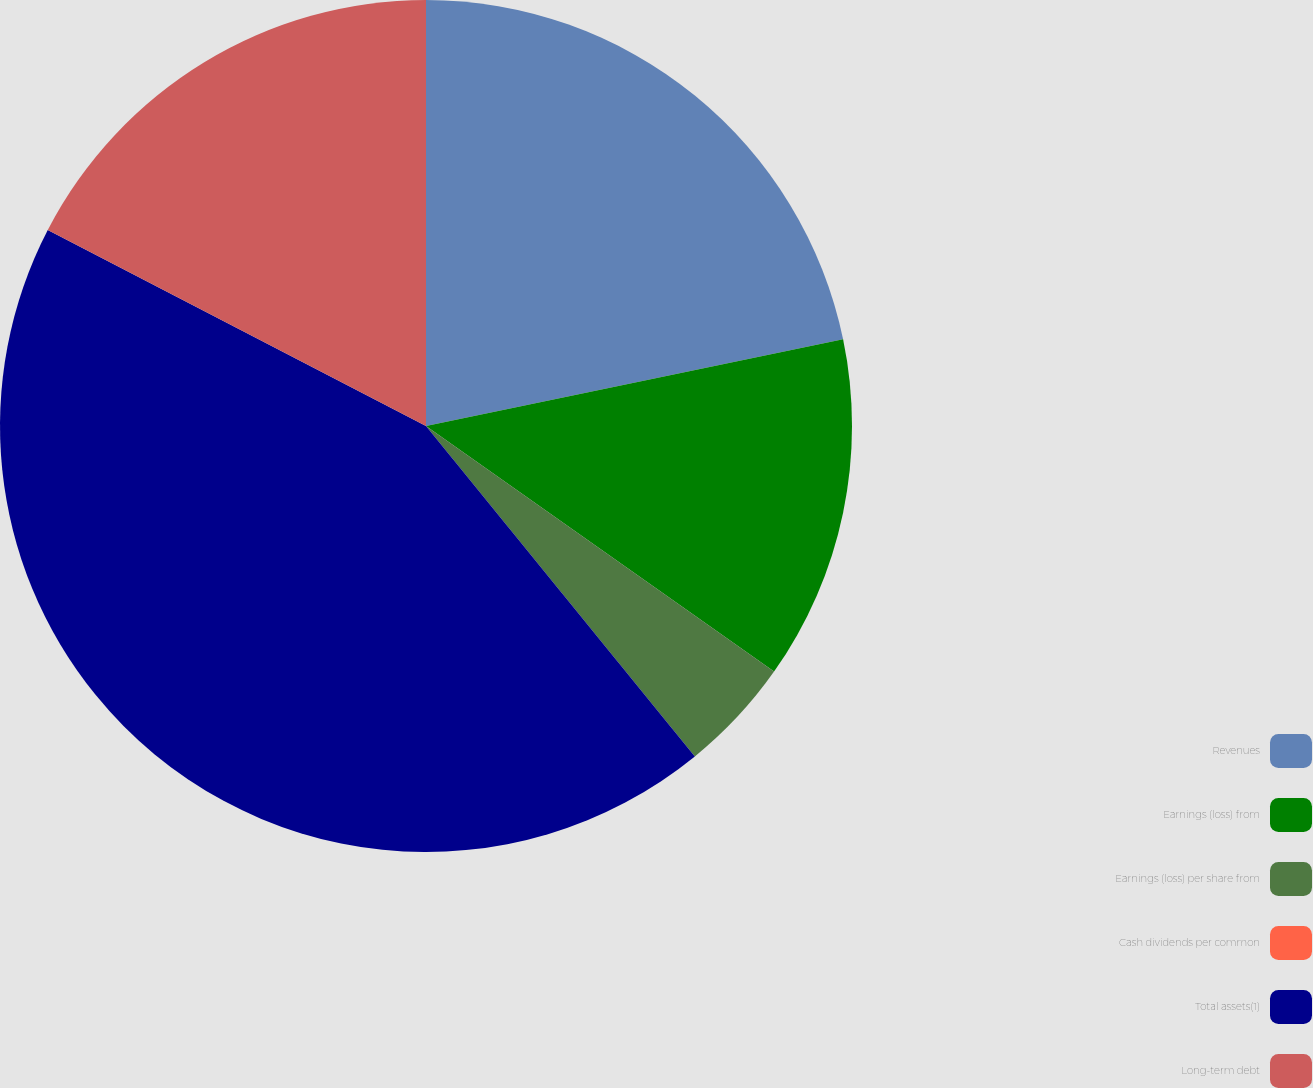Convert chart. <chart><loc_0><loc_0><loc_500><loc_500><pie_chart><fcel>Revenues<fcel>Earnings (loss) from<fcel>Earnings (loss) per share from<fcel>Cash dividends per common<fcel>Total assets(1)<fcel>Long-term debt<nl><fcel>21.74%<fcel>13.04%<fcel>4.35%<fcel>0.0%<fcel>43.48%<fcel>17.39%<nl></chart> 